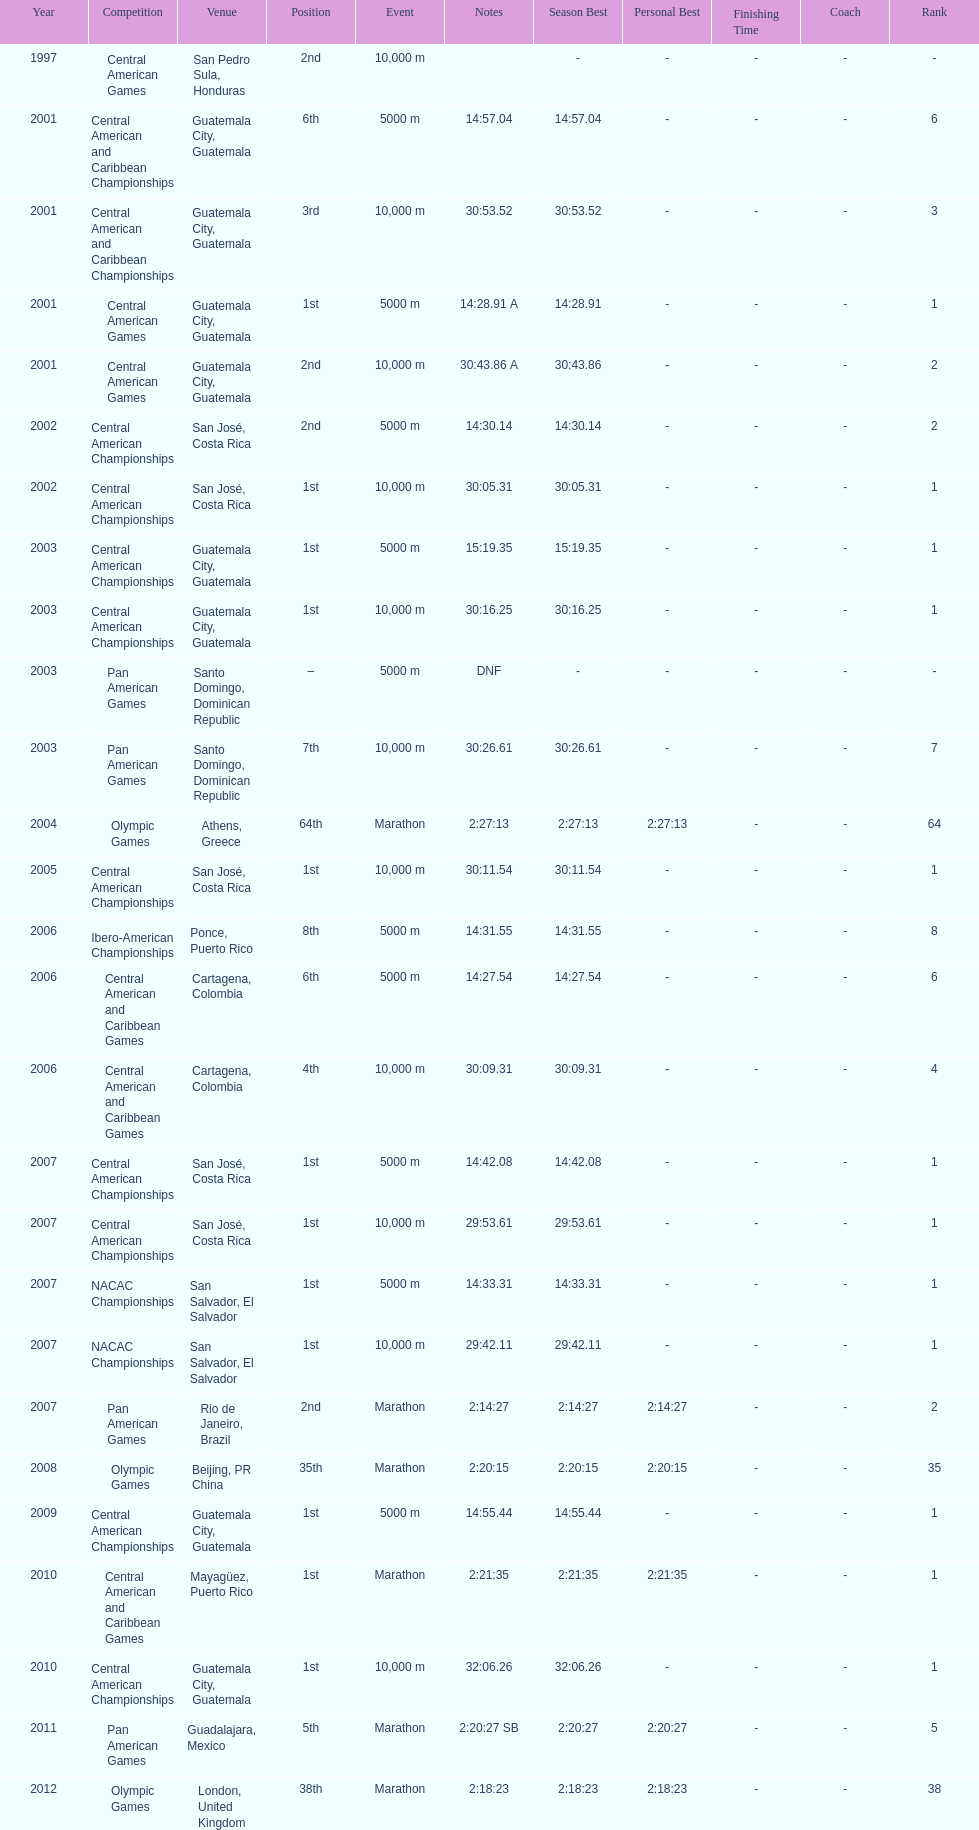How many times has this athlete not finished in a competition? 1. 